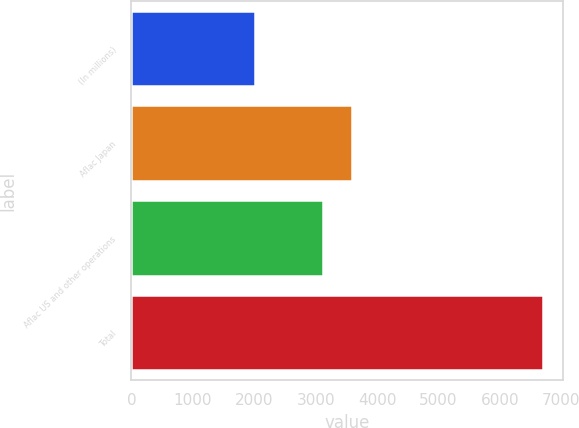Convert chart to OTSL. <chart><loc_0><loc_0><loc_500><loc_500><bar_chart><fcel>(In millions)<fcel>Aflac Japan<fcel>Aflac US and other operations<fcel>Total<nl><fcel>2005<fcel>3586.7<fcel>3118<fcel>6692<nl></chart> 